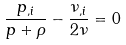<formula> <loc_0><loc_0><loc_500><loc_500>\frac { { p _ { , i } } } { p + \rho } - \frac { { \nu _ { , i } } } { 2 \nu } = 0</formula> 